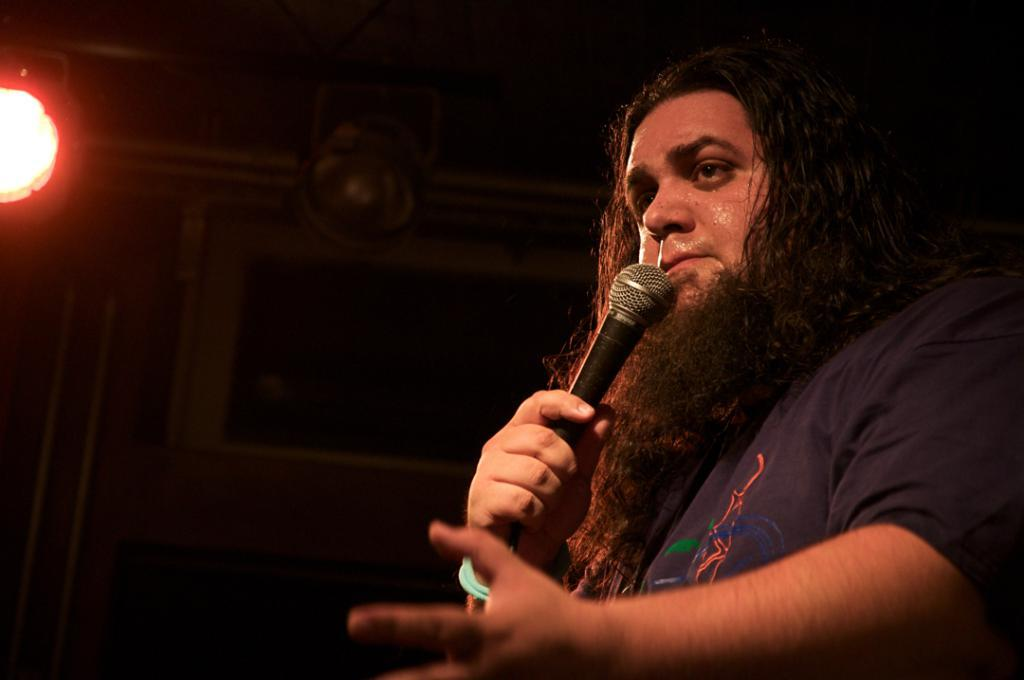Who is present in the image? There is a man in the image. What is the man holding in his hand? The man is holding a microphone in his hand. Can you describe any other objects or features in the image? There is a light on the roof in the image. What type of spoon can be seen in the image? There is no spoon present in the image. Is there a tent visible in the image? No, there is no tent present in the image. 